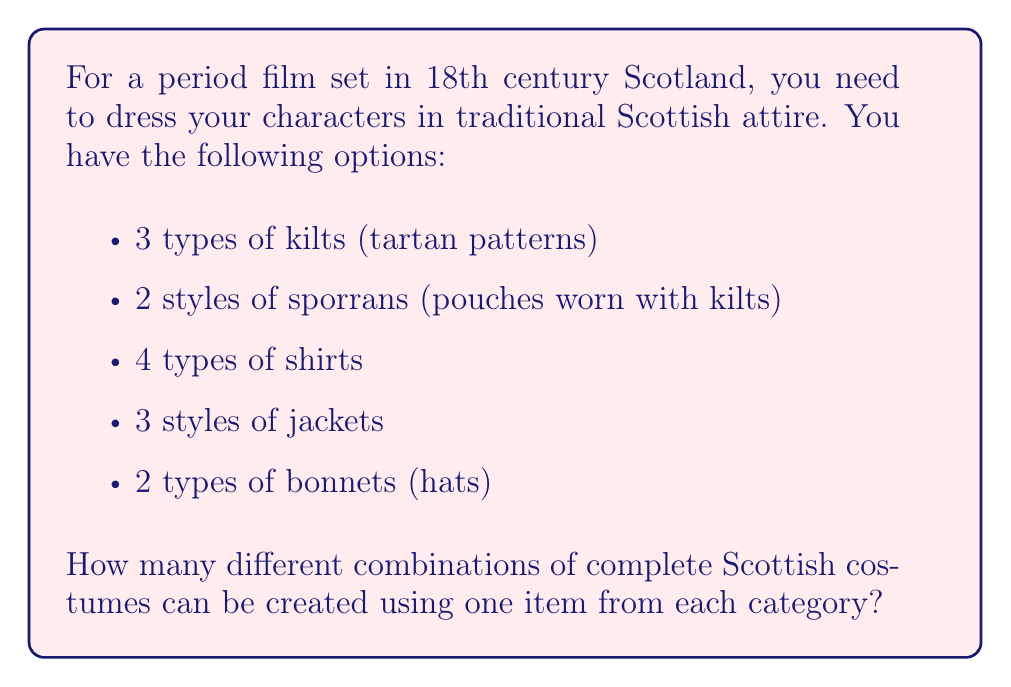Give your solution to this math problem. To solve this problem, we'll use the multiplication principle of counting. This principle states that if we have $m$ ways of doing something and $n$ ways of doing another thing, then there are $m \times n$ ways of doing both things.

Let's break down the problem:

1. We have 5 categories of clothing items:
   - Kilts: 3 options
   - Sporrans: 2 options
   - Shirts: 4 options
   - Jackets: 3 options
   - Bonnets: 2 options

2. For each complete costume, we need to choose one item from each category.

3. The number of ways to choose each item is independent of the choices for other items.

4. Therefore, we multiply the number of options for each category:

   $$ \text{Total combinations} = 3 \times 2 \times 4 \times 3 \times 2 $$

5. Calculating this:
   $$ \text{Total combinations} = 3 \times 2 \times 4 \times 3 \times 2 = 144 $$

Thus, there are 144 different possible combinations of complete Scottish costumes using one item from each category.
Answer: 144 combinations 